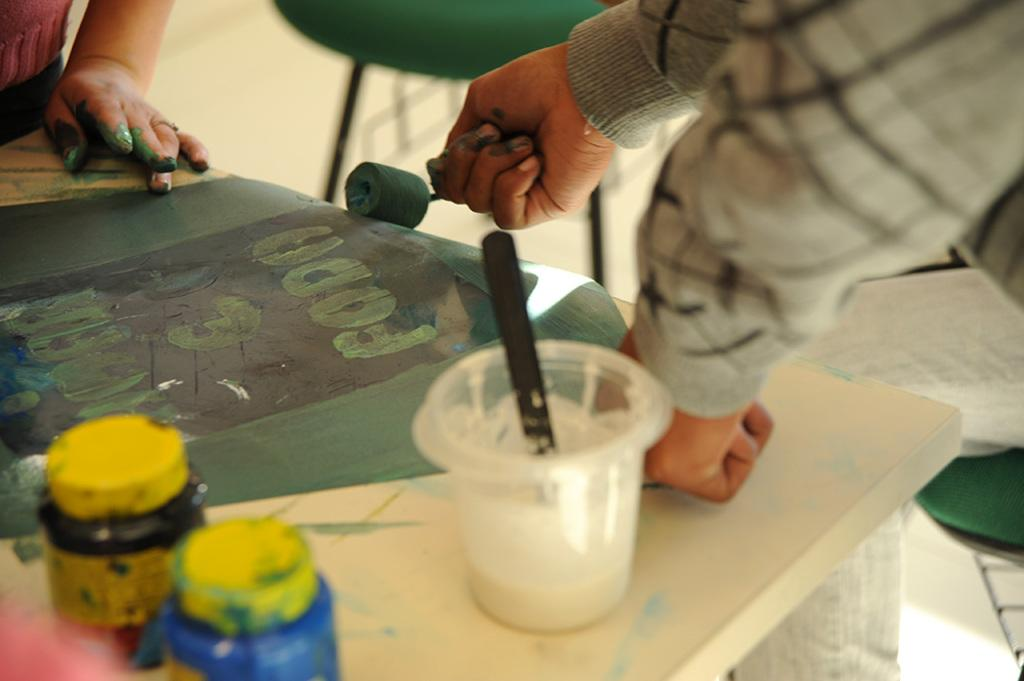What type of surface can be seen in the image? There is a table in the image. What items are on the table? Paint bottles are present on the table. What is being painted in the image? There is a painted sheet in the image. What are the people in the image doing? People are painting the sheet. Can you see a pipe being used to comb the people's hair in the image? There is no pipe or combing activity present in the image. The people are painting a sheet, and there are paint bottles on the table. 